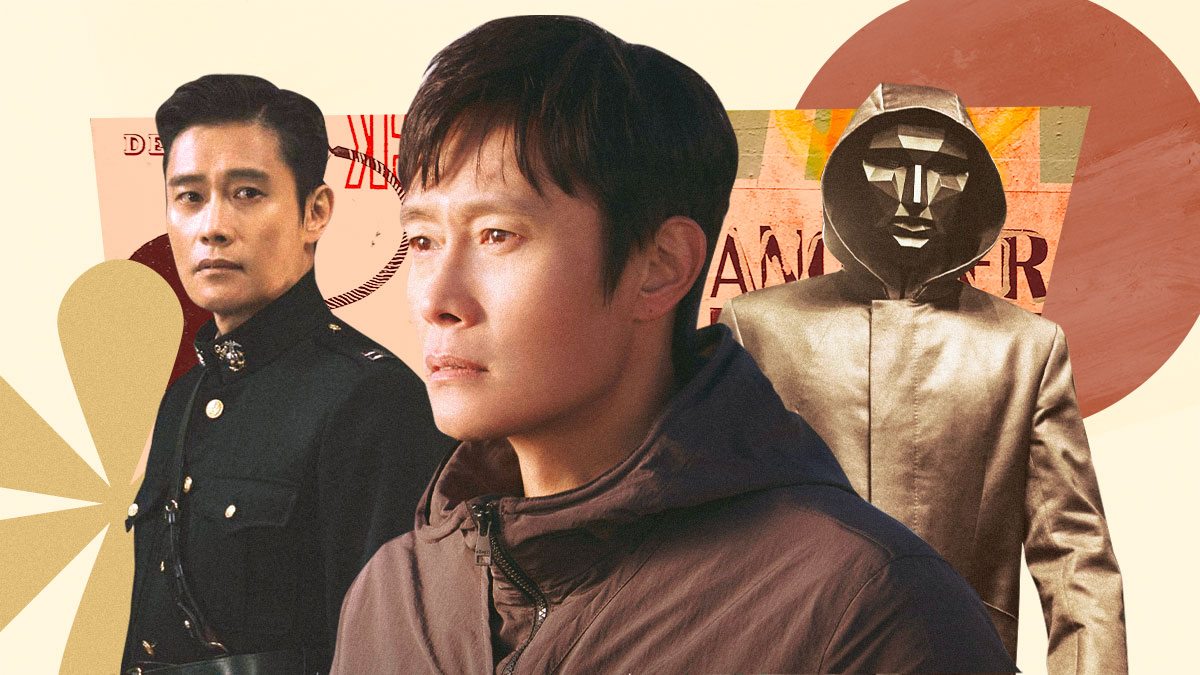How do the background colors influence the perception of these images? The warm backdrop of oranges, yellows, and reds serves to highlight the characters while also imparting an emotional tone to each depiction. The colors evoke feelings of passion, intensity, and perhaps turmoil, which may reflect the inner conflicts or dramatic experiences of the characters. Does the positioning of the characters in the image suggest anything about their narrative importance? Yes, the central placement of the character in civilian clothes could suggest his role as the emotional or narrative anchor, around which the other more dramatically costumed characters revolve. This central figure might represent a more grounded, relatable persona, with the other figures portraying his alter egos or different facets of his identity. 